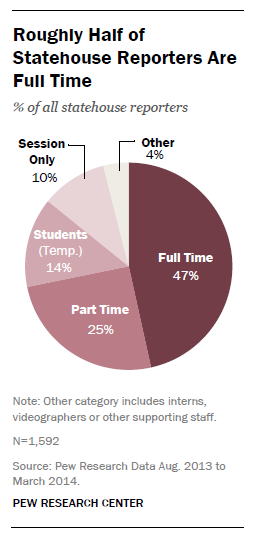Identify some key points in this picture. The sum of the values of the three smallest segments is greater than the value of the second largest segment. The value of the 'Other' segment is 4. 